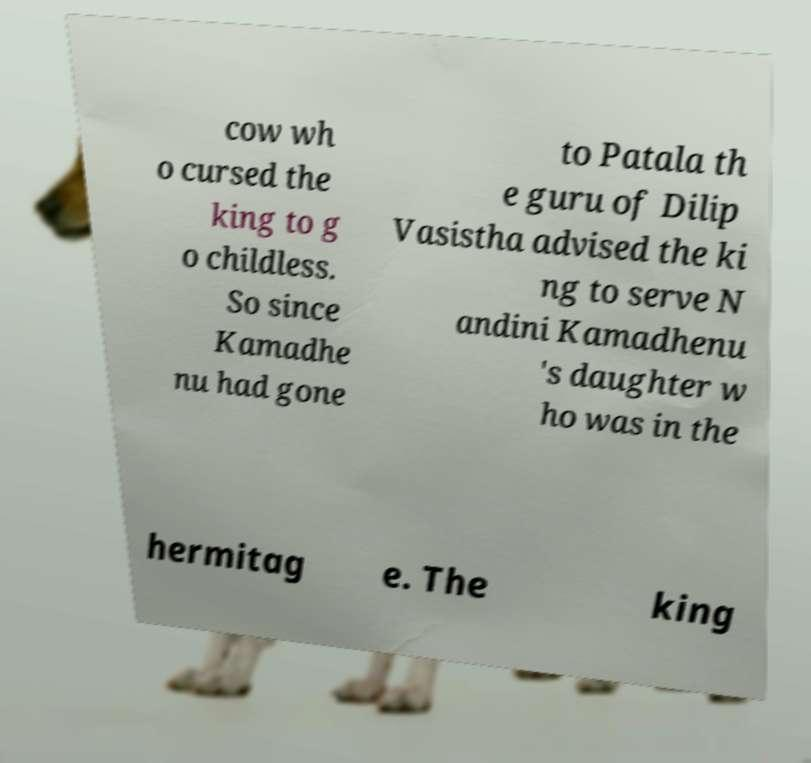I need the written content from this picture converted into text. Can you do that? cow wh o cursed the king to g o childless. So since Kamadhe nu had gone to Patala th e guru of Dilip Vasistha advised the ki ng to serve N andini Kamadhenu 's daughter w ho was in the hermitag e. The king 